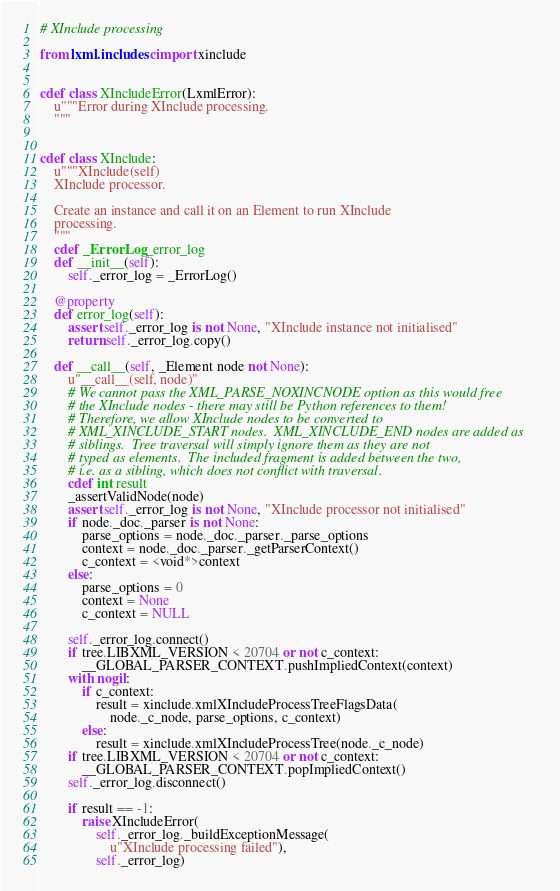Convert code to text. <code><loc_0><loc_0><loc_500><loc_500><_Cython_># XInclude processing

from lxml.includes cimport xinclude


cdef class XIncludeError(LxmlError):
    u"""Error during XInclude processing.
    """


cdef class XInclude:
    u"""XInclude(self)
    XInclude processor.

    Create an instance and call it on an Element to run XInclude
    processing.
    """
    cdef _ErrorLog _error_log
    def __init__(self):
        self._error_log = _ErrorLog()

    @property
    def error_log(self):
        assert self._error_log is not None, "XInclude instance not initialised"
        return self._error_log.copy()

    def __call__(self, _Element node not None):
        u"__call__(self, node)"
        # We cannot pass the XML_PARSE_NOXINCNODE option as this would free
        # the XInclude nodes - there may still be Python references to them!
        # Therefore, we allow XInclude nodes to be converted to
        # XML_XINCLUDE_START nodes.  XML_XINCLUDE_END nodes are added as
        # siblings.  Tree traversal will simply ignore them as they are not
        # typed as elements.  The included fragment is added between the two,
        # i.e. as a sibling, which does not conflict with traversal.
        cdef int result
        _assertValidNode(node)
        assert self._error_log is not None, "XInclude processor not initialised"
        if node._doc._parser is not None:
            parse_options = node._doc._parser._parse_options
            context = node._doc._parser._getParserContext()
            c_context = <void*>context
        else:
            parse_options = 0
            context = None
            c_context = NULL

        self._error_log.connect()
        if tree.LIBXML_VERSION < 20704 or not c_context:
            __GLOBAL_PARSER_CONTEXT.pushImpliedContext(context)
        with nogil:
            if c_context:
                result = xinclude.xmlXIncludeProcessTreeFlagsData(
                    node._c_node, parse_options, c_context)
            else:
                result = xinclude.xmlXIncludeProcessTree(node._c_node)
        if tree.LIBXML_VERSION < 20704 or not c_context:
            __GLOBAL_PARSER_CONTEXT.popImpliedContext()
        self._error_log.disconnect()

        if result == -1:
            raise XIncludeError(
                self._error_log._buildExceptionMessage(
                    u"XInclude processing failed"),
                self._error_log)
</code> 